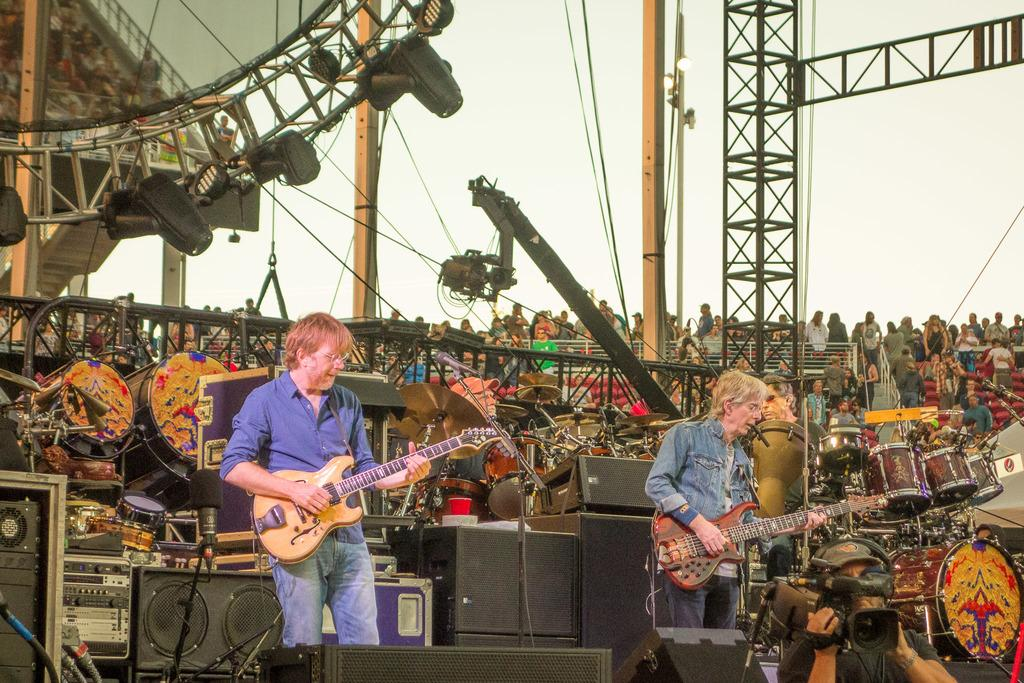What can be seen in the background of the image? The sky is visible in the background of the image. Who or what is present in the image? There are people in the image. What type of barrier is in the image? There is a fence in the image. What musical instruments are visible in the image? There are drums and two people holding guitars in the image. How many legs does the writer have in the image? There is no writer present in the image. What type of pan is being used to play the drums in the image? There is no pan being used to play the drums in the image; the drums are played with drumsticks. 